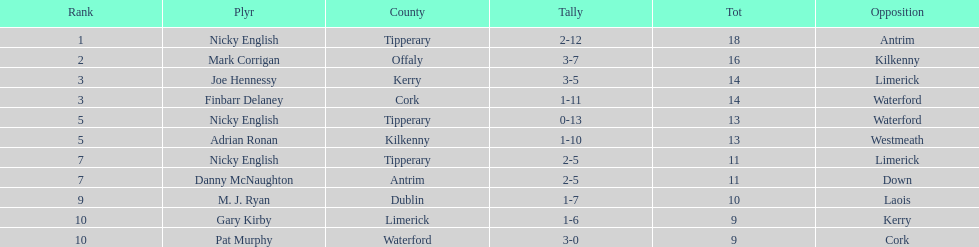Give me the full table as a dictionary. {'header': ['Rank', 'Plyr', 'County', 'Tally', 'Tot', 'Opposition'], 'rows': [['1', 'Nicky English', 'Tipperary', '2-12', '18', 'Antrim'], ['2', 'Mark Corrigan', 'Offaly', '3-7', '16', 'Kilkenny'], ['3', 'Joe Hennessy', 'Kerry', '3-5', '14', 'Limerick'], ['3', 'Finbarr Delaney', 'Cork', '1-11', '14', 'Waterford'], ['5', 'Nicky English', 'Tipperary', '0-13', '13', 'Waterford'], ['5', 'Adrian Ronan', 'Kilkenny', '1-10', '13', 'Westmeath'], ['7', 'Nicky English', 'Tipperary', '2-5', '11', 'Limerick'], ['7', 'Danny McNaughton', 'Antrim', '2-5', '11', 'Down'], ['9', 'M. J. Ryan', 'Dublin', '1-7', '10', 'Laois'], ['10', 'Gary Kirby', 'Limerick', '1-6', '9', 'Kerry'], ['10', 'Pat Murphy', 'Waterford', '3-0', '9', 'Cork']]} Who ranked above mark corrigan? Nicky English. 